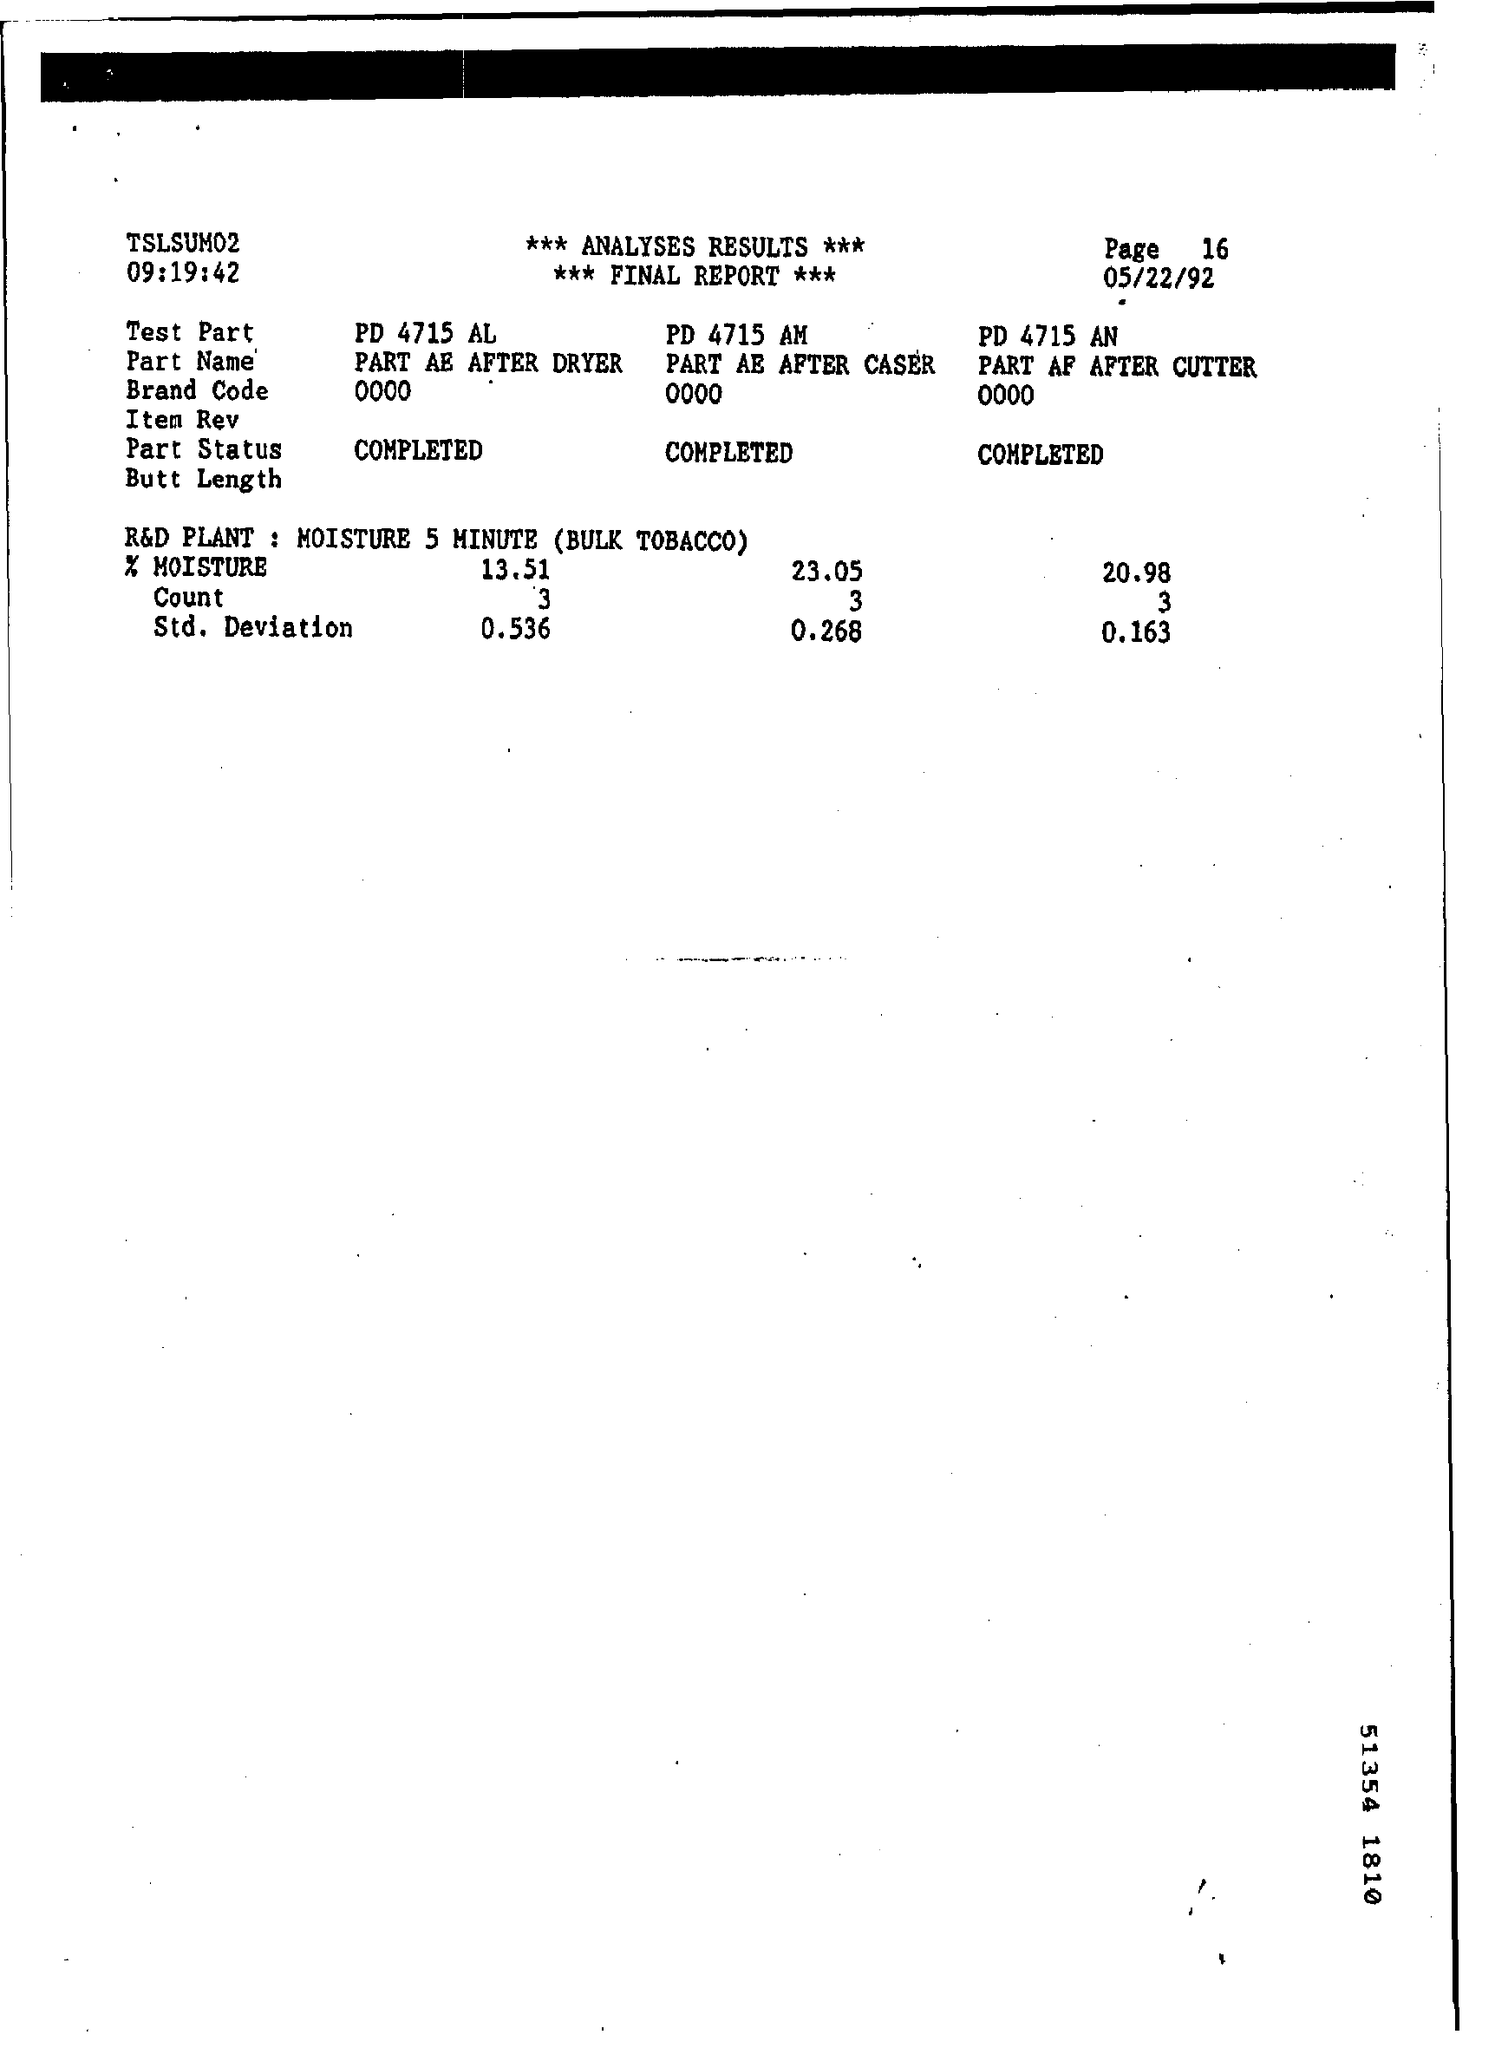Indicate a few pertinent items in this graphic. The name of the plant mentioned at the end of the video is the R&D Plant. What is the date mentioned? May 22nd, 1992. 